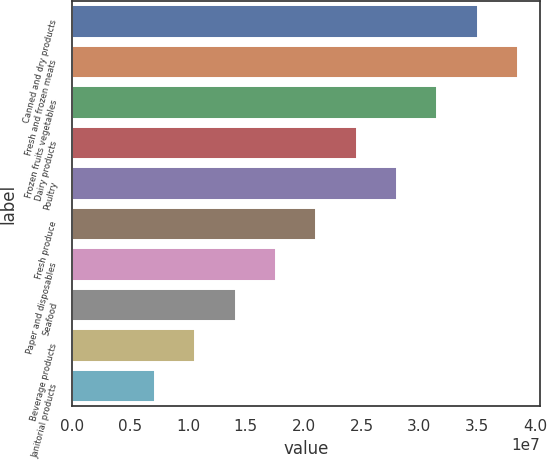Convert chart. <chart><loc_0><loc_0><loc_500><loc_500><bar_chart><fcel>Canned and dry products<fcel>Fresh and frozen meats<fcel>Frozen fruits vegetables<fcel>Dairy products<fcel>Poultry<fcel>Fresh produce<fcel>Paper and disposables<fcel>Seafood<fcel>Beverage products<fcel>Janitorial products<nl><fcel>3.50421e+07<fcel>3.85257e+07<fcel>3.15584e+07<fcel>2.45911e+07<fcel>2.80747e+07<fcel>2.11074e+07<fcel>1.76237e+07<fcel>1.41401e+07<fcel>1.06564e+07<fcel>7.17272e+06<nl></chart> 